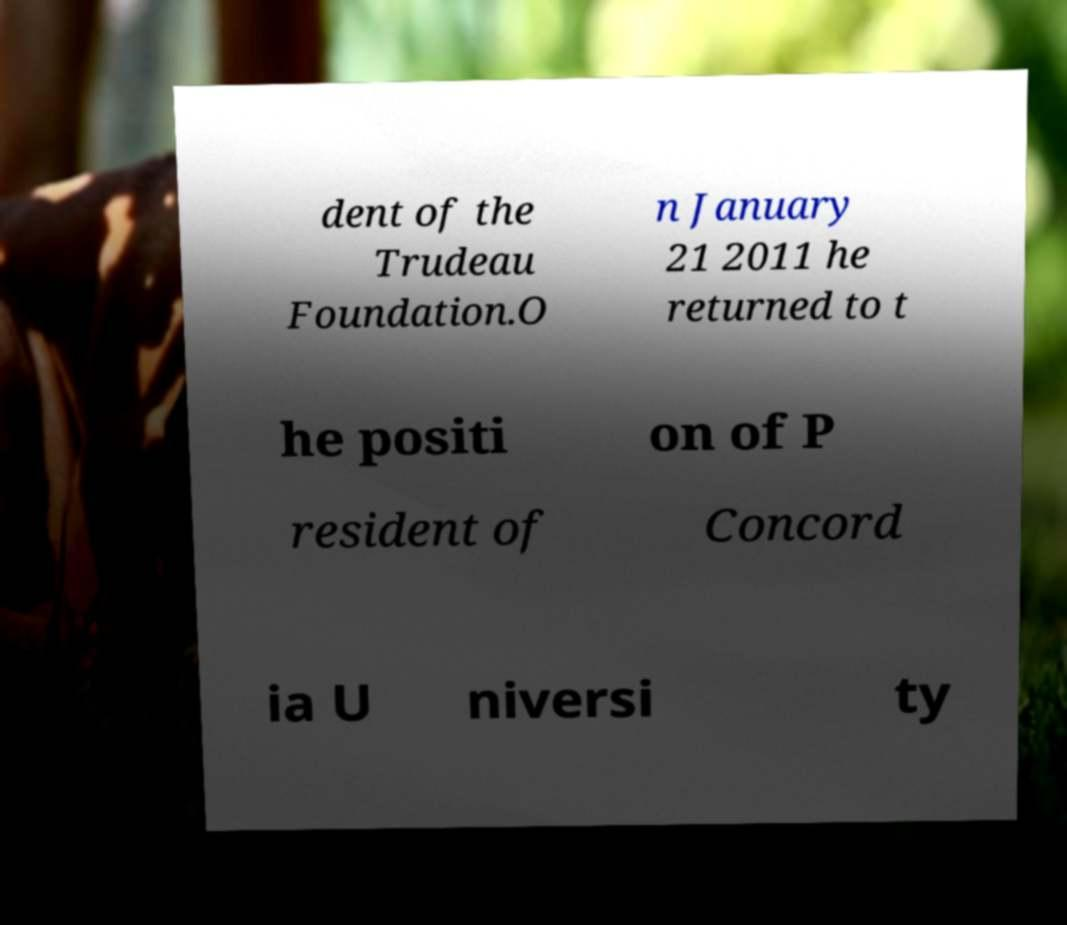What messages or text are displayed in this image? I need them in a readable, typed format. dent of the Trudeau Foundation.O n January 21 2011 he returned to t he positi on of P resident of Concord ia U niversi ty 